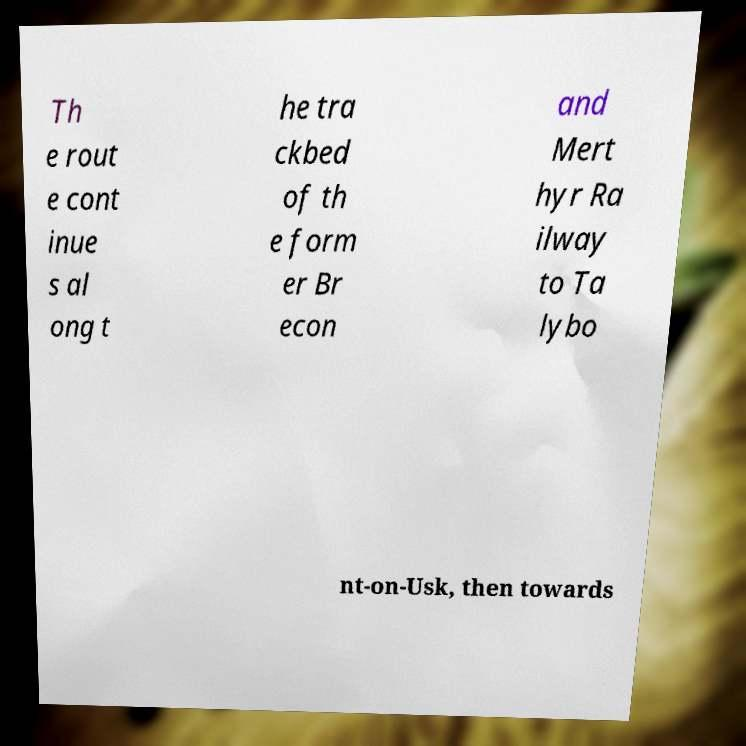For documentation purposes, I need the text within this image transcribed. Could you provide that? Th e rout e cont inue s al ong t he tra ckbed of th e form er Br econ and Mert hyr Ra ilway to Ta lybo nt-on-Usk, then towards 